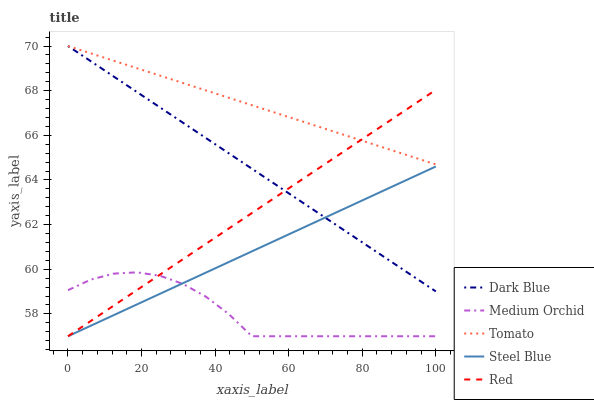Does Medium Orchid have the minimum area under the curve?
Answer yes or no. Yes. Does Tomato have the maximum area under the curve?
Answer yes or no. Yes. Does Dark Blue have the minimum area under the curve?
Answer yes or no. No. Does Dark Blue have the maximum area under the curve?
Answer yes or no. No. Is Tomato the smoothest?
Answer yes or no. Yes. Is Medium Orchid the roughest?
Answer yes or no. Yes. Is Dark Blue the smoothest?
Answer yes or no. No. Is Dark Blue the roughest?
Answer yes or no. No. Does Medium Orchid have the lowest value?
Answer yes or no. Yes. Does Dark Blue have the lowest value?
Answer yes or no. No. Does Dark Blue have the highest value?
Answer yes or no. Yes. Does Medium Orchid have the highest value?
Answer yes or no. No. Is Medium Orchid less than Tomato?
Answer yes or no. Yes. Is Dark Blue greater than Medium Orchid?
Answer yes or no. Yes. Does Tomato intersect Dark Blue?
Answer yes or no. Yes. Is Tomato less than Dark Blue?
Answer yes or no. No. Is Tomato greater than Dark Blue?
Answer yes or no. No. Does Medium Orchid intersect Tomato?
Answer yes or no. No. 